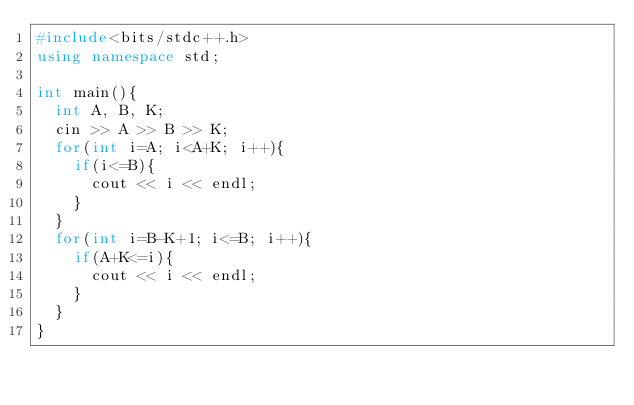<code> <loc_0><loc_0><loc_500><loc_500><_C++_>#include<bits/stdc++.h>
using namespace std;

int main(){
  int A, B, K;
  cin >> A >> B >> K;
  for(int i=A; i<A+K; i++){
    if(i<=B){
      cout << i << endl;
    }
  }
  for(int i=B-K+1; i<=B; i++){
    if(A+K<=i){
      cout << i << endl;
    }
  }
}</code> 